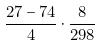Convert formula to latex. <formula><loc_0><loc_0><loc_500><loc_500>\frac { 2 7 - 7 4 } { 4 } \cdot \frac { 8 } { 2 9 8 }</formula> 